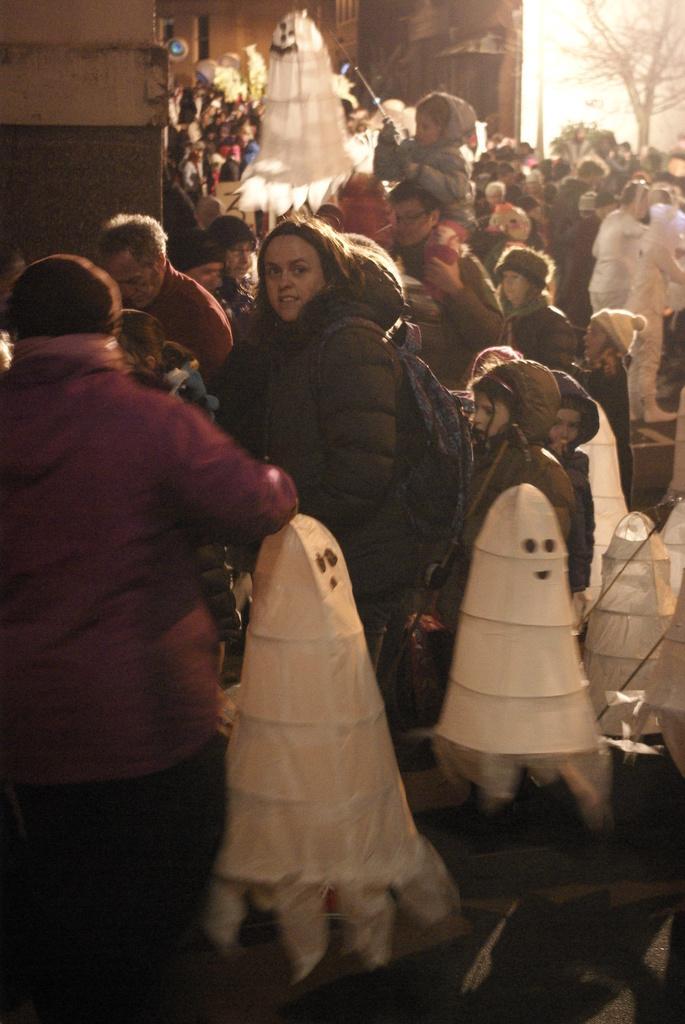How would you summarize this image in a sentence or two? In this image we can see the building, one object attached to the building, one woman wearing a bag in the middle of the image, some people are standing, some people are walking, some people are holding objects, one tree, some white objects on the road, some children are standing, one man holding a child, one white board with a number, two persons in white costume and it looks like a sunlight in the background. 